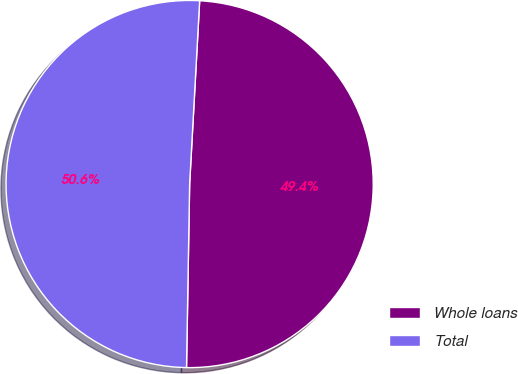Convert chart. <chart><loc_0><loc_0><loc_500><loc_500><pie_chart><fcel>Whole loans<fcel>Total<nl><fcel>49.4%<fcel>50.6%<nl></chart> 